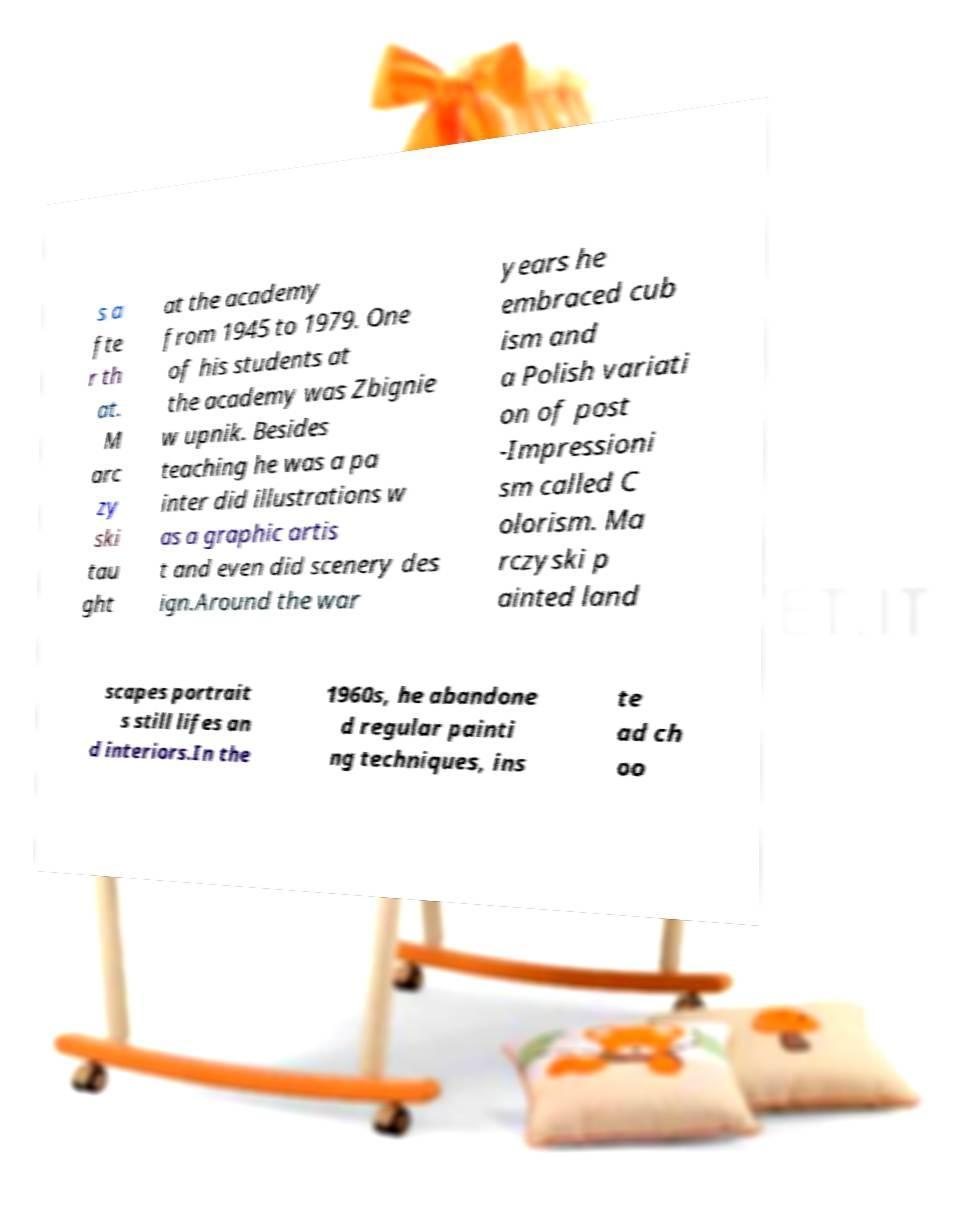I need the written content from this picture converted into text. Can you do that? s a fte r th at. M arc zy ski tau ght at the academy from 1945 to 1979. One of his students at the academy was Zbignie w upnik. Besides teaching he was a pa inter did illustrations w as a graphic artis t and even did scenery des ign.Around the war years he embraced cub ism and a Polish variati on of post -Impressioni sm called C olorism. Ma rczyski p ainted land scapes portrait s still lifes an d interiors.In the 1960s, he abandone d regular painti ng techniques, ins te ad ch oo 